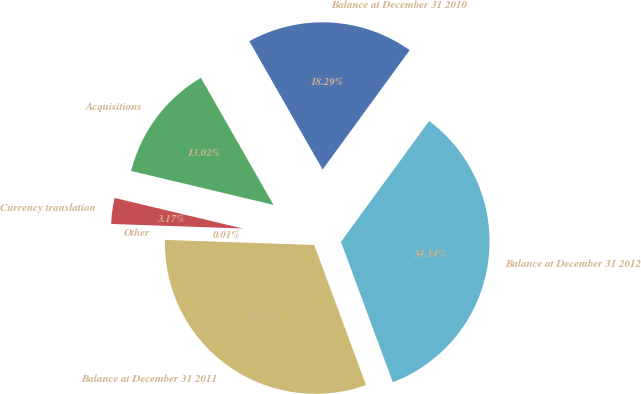Convert chart. <chart><loc_0><loc_0><loc_500><loc_500><pie_chart><fcel>Balance at December 31 2010<fcel>Acquisitions<fcel>Currency translation<fcel>Other<fcel>Balance at December 31 2011<fcel>Balance at December 31 2012<nl><fcel>18.29%<fcel>13.02%<fcel>3.17%<fcel>0.01%<fcel>31.18%<fcel>34.34%<nl></chart> 